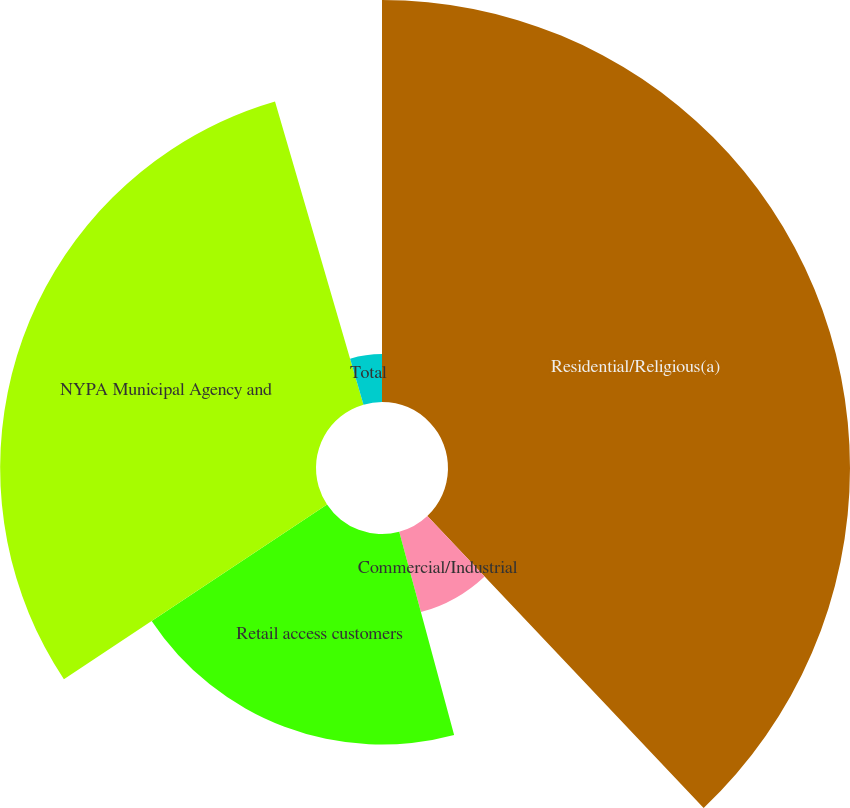Convert chart. <chart><loc_0><loc_0><loc_500><loc_500><pie_chart><fcel>Residential/Religious(a)<fcel>Commercial/Industrial<fcel>Retail access customers<fcel>NYPA Municipal Agency and<fcel>Total<nl><fcel>37.94%<fcel>7.86%<fcel>19.87%<fcel>29.81%<fcel>4.52%<nl></chart> 